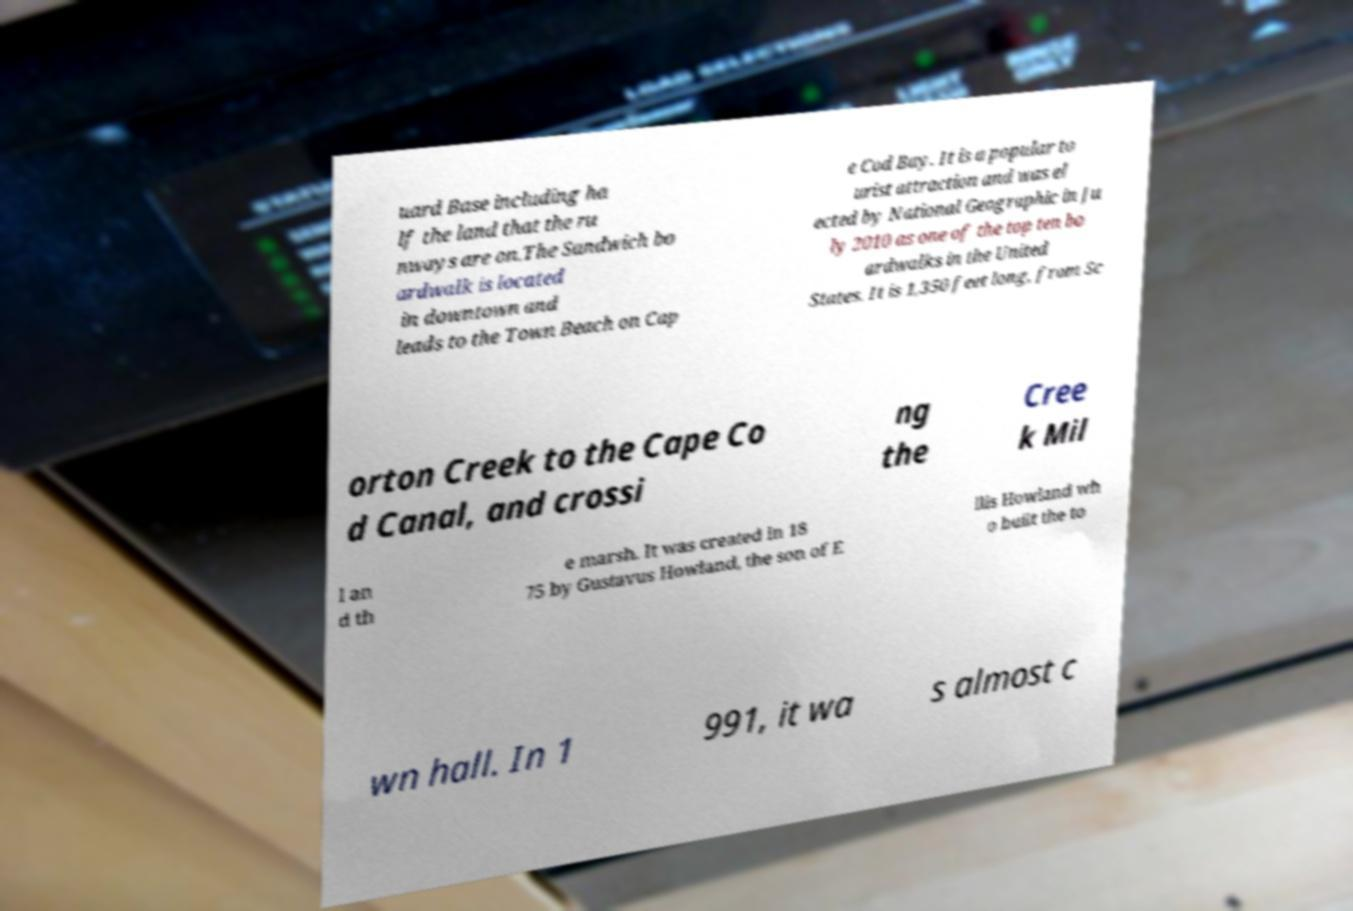Could you assist in decoding the text presented in this image and type it out clearly? uard Base including ha lf the land that the ru nways are on.The Sandwich bo ardwalk is located in downtown and leads to the Town Beach on Cap e Cod Bay. It is a popular to urist attraction and was el ected by National Geographic in Ju ly 2010 as one of the top ten bo ardwalks in the United States. It is 1,350 feet long, from Sc orton Creek to the Cape Co d Canal, and crossi ng the Cree k Mil l an d th e marsh. It was created in 18 75 by Gustavus Howland, the son of E llis Howland wh o built the to wn hall. In 1 991, it wa s almost c 